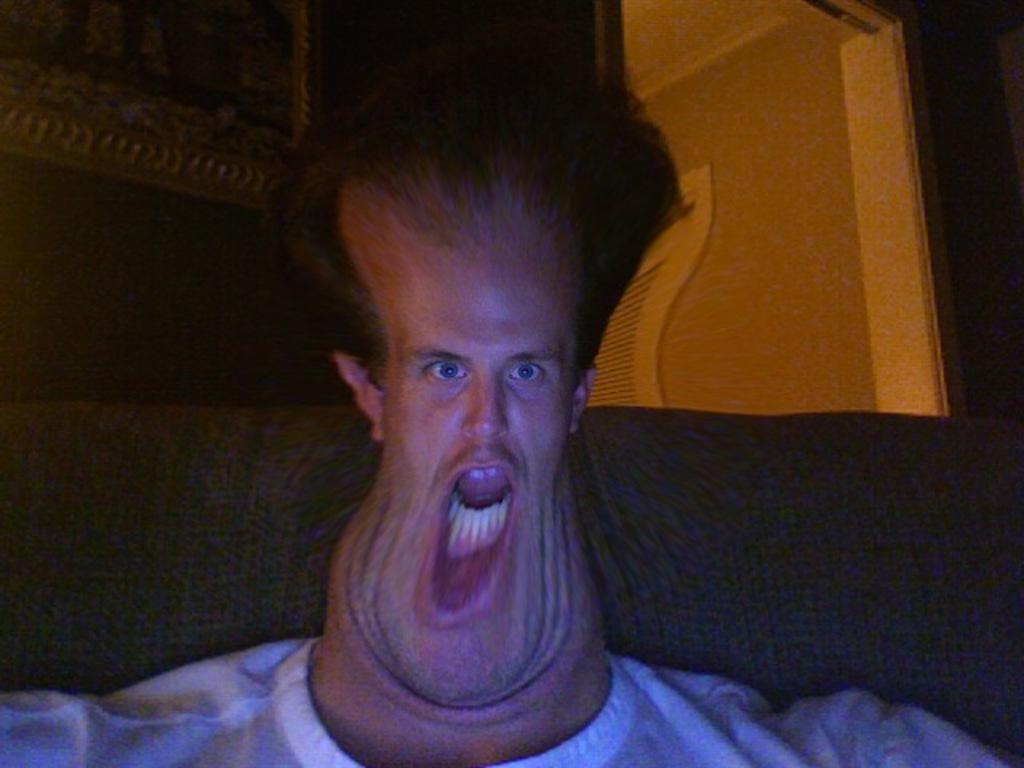What is the person in the image doing? The person is sitting on a sofa in the image. What can be seen on the wall in the image? There is a wall with a picture frame attached to it in the image. Where is the door located in the image? The door is on the right side of the image. What type of linen is draped over the sofa in the image? There is no linen draped over the sofa in the image; the sofa is visible without any additional coverings. 